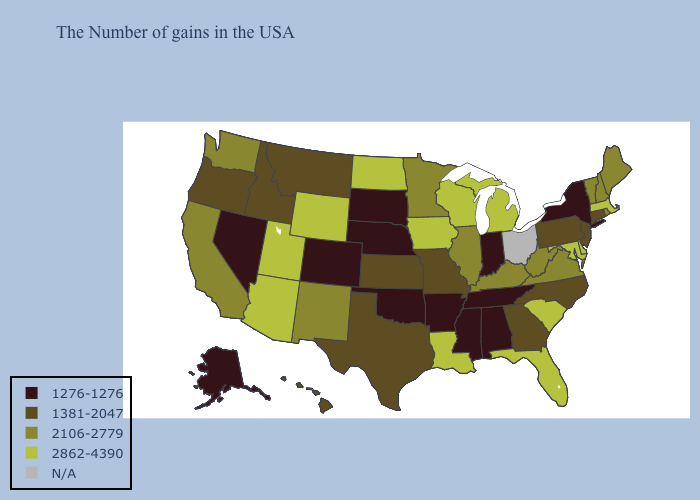Among the states that border Tennessee , which have the highest value?
Be succinct. Virginia, Kentucky. What is the value of Montana?
Keep it brief. 1381-2047. Among the states that border Connecticut , does New York have the highest value?
Be succinct. No. Does the map have missing data?
Short answer required. Yes. Name the states that have a value in the range N/A?
Answer briefly. Ohio. Name the states that have a value in the range 2106-2779?
Answer briefly. Maine, Rhode Island, New Hampshire, Vermont, Virginia, West Virginia, Kentucky, Illinois, Minnesota, New Mexico, California, Washington. Which states hav the highest value in the South?
Quick response, please. Delaware, Maryland, South Carolina, Florida, Louisiana. Name the states that have a value in the range N/A?
Answer briefly. Ohio. What is the value of Rhode Island?
Quick response, please. 2106-2779. Which states have the lowest value in the USA?
Concise answer only. New York, Indiana, Alabama, Tennessee, Mississippi, Arkansas, Nebraska, Oklahoma, South Dakota, Colorado, Nevada, Alaska. What is the lowest value in states that border Arizona?
Write a very short answer. 1276-1276. Name the states that have a value in the range 1276-1276?
Short answer required. New York, Indiana, Alabama, Tennessee, Mississippi, Arkansas, Nebraska, Oklahoma, South Dakota, Colorado, Nevada, Alaska. Name the states that have a value in the range 1276-1276?
Quick response, please. New York, Indiana, Alabama, Tennessee, Mississippi, Arkansas, Nebraska, Oklahoma, South Dakota, Colorado, Nevada, Alaska. What is the value of Mississippi?
Answer briefly. 1276-1276. 